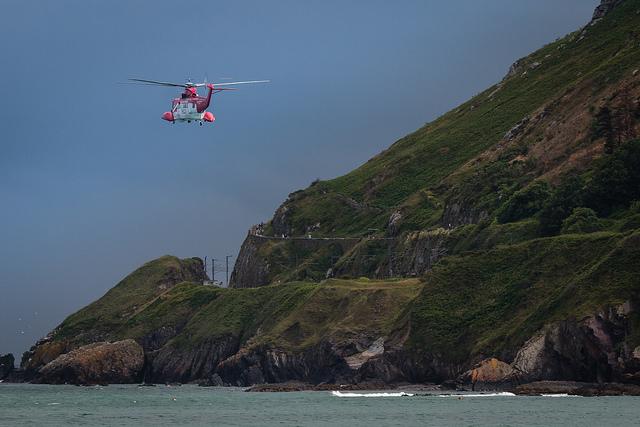Where is the helicopter?
Short answer required. In air. Is the aircraft landing?
Keep it brief. No. What is in the air?
Be succinct. Helicopter. 